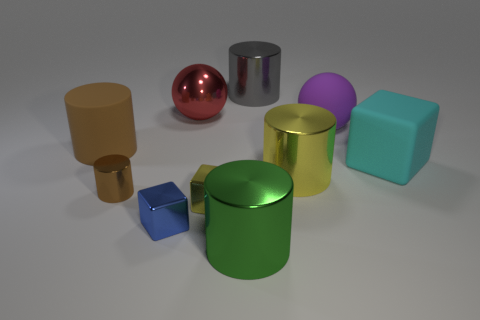Subtract all yellow cylinders. How many cylinders are left? 4 Subtract all big brown rubber cylinders. How many cylinders are left? 4 Subtract all cyan cylinders. Subtract all green cubes. How many cylinders are left? 5 Subtract all balls. How many objects are left? 8 Add 6 tiny brown cylinders. How many tiny brown cylinders are left? 7 Add 6 small brown shiny things. How many small brown shiny things exist? 7 Subtract 0 brown blocks. How many objects are left? 10 Subtract all large yellow cylinders. Subtract all tiny brown metallic objects. How many objects are left? 8 